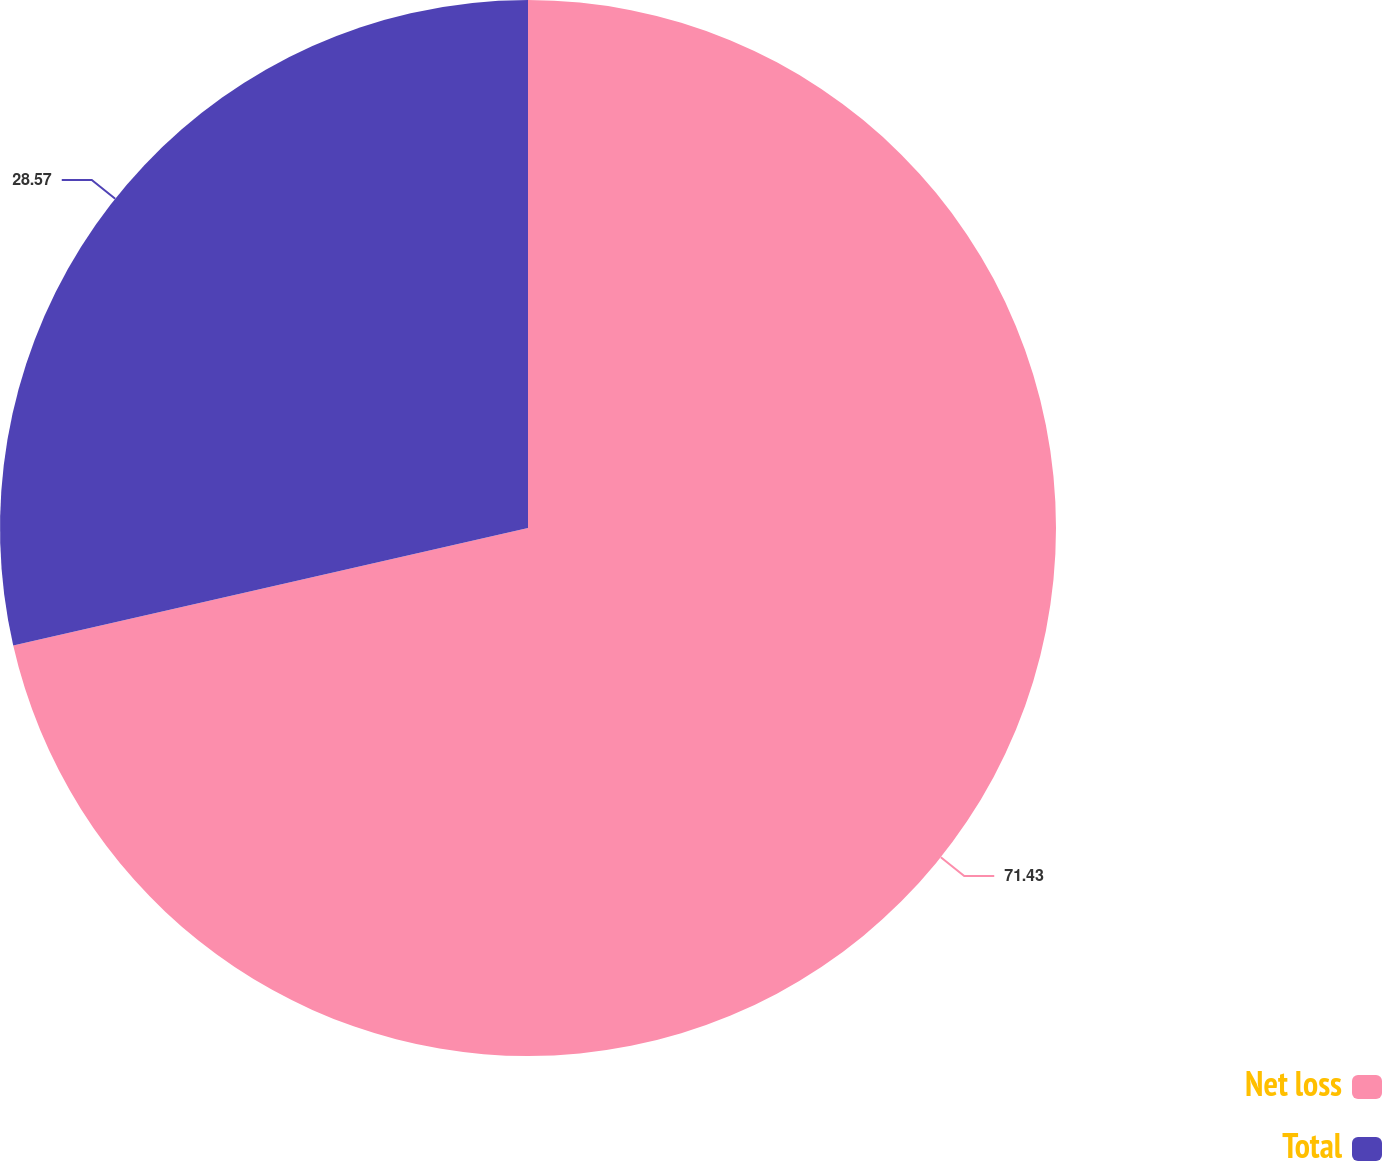Convert chart to OTSL. <chart><loc_0><loc_0><loc_500><loc_500><pie_chart><fcel>Net loss<fcel>Total<nl><fcel>71.43%<fcel>28.57%<nl></chart> 